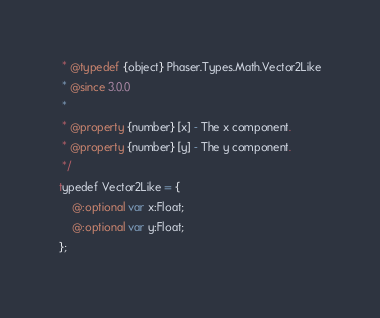Convert code to text. <code><loc_0><loc_0><loc_500><loc_500><_Haxe_> * @typedef {object} Phaser.Types.Math.Vector2Like
 * @since 3.0.0
 *
 * @property {number} [x] - The x component.
 * @property {number} [y] - The y component.
 */
typedef Vector2Like = {
    @:optional var x:Float;
    @:optional var y:Float;
};
</code> 